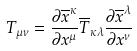Convert formula to latex. <formula><loc_0><loc_0><loc_500><loc_500>T _ { \mu \nu } = \frac { \partial \overline { x } ^ { \kappa } } { \partial x ^ { \mu } } \overline { T } _ { \kappa \lambda } \frac { \partial \overline { x } ^ { \lambda } } { \partial x ^ { \nu } }</formula> 